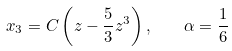Convert formula to latex. <formula><loc_0><loc_0><loc_500><loc_500>x _ { 3 } = C \left ( z - \frac { 5 } { 3 } z ^ { 3 } \right ) , \quad \alpha = \frac { 1 } { 6 }</formula> 